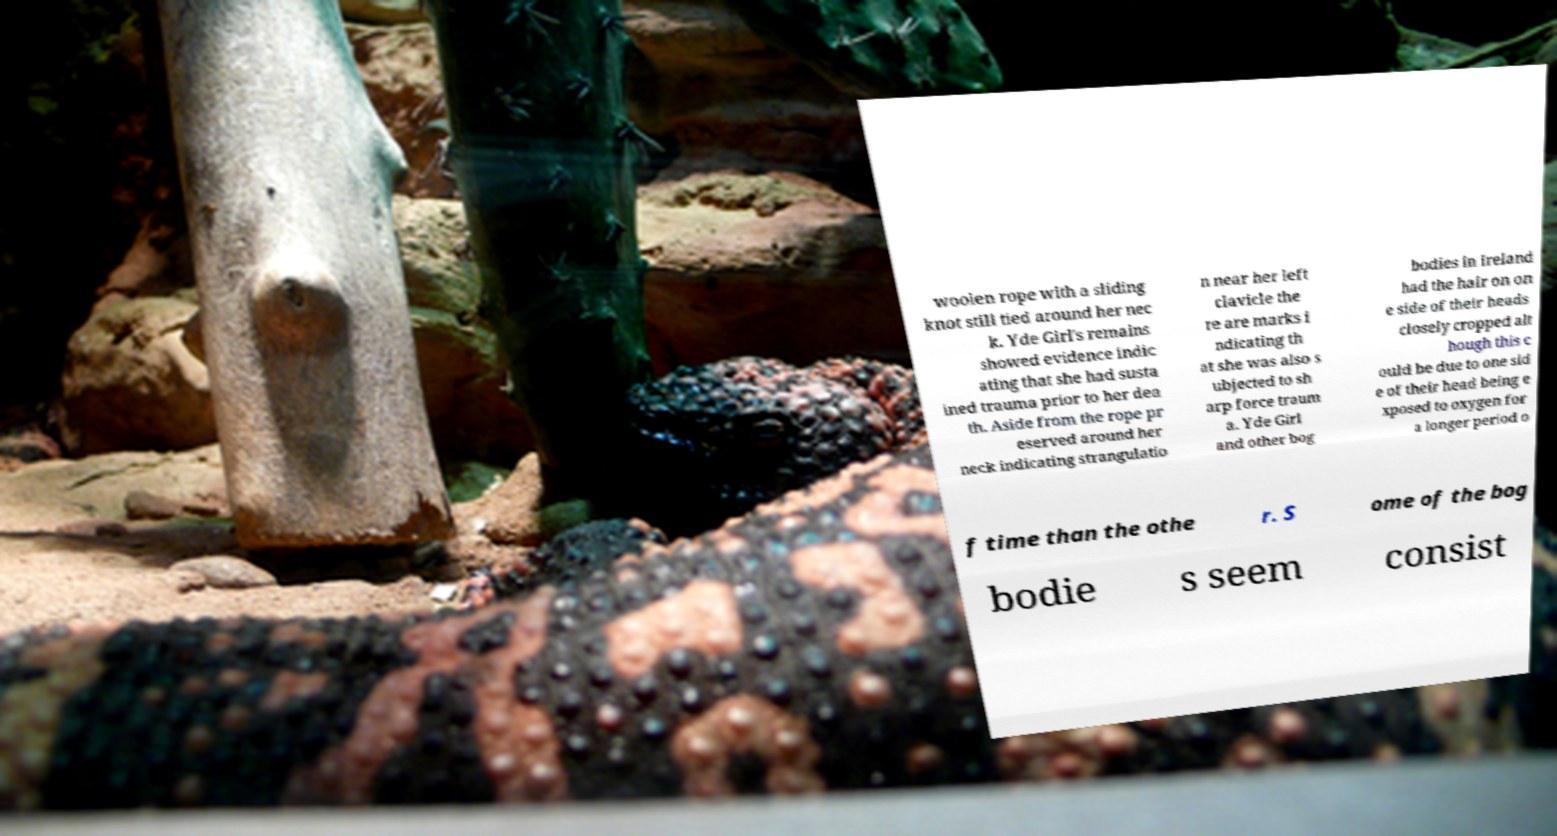Could you assist in decoding the text presented in this image and type it out clearly? woolen rope with a sliding knot still tied around her nec k. Yde Girl's remains showed evidence indic ating that she had susta ined trauma prior to her dea th. Aside from the rope pr eserved around her neck indicating strangulatio n near her left clavicle the re are marks i ndicating th at she was also s ubjected to sh arp force traum a. Yde Girl and other bog bodies in Ireland had the hair on on e side of their heads closely cropped alt hough this c ould be due to one sid e of their head being e xposed to oxygen for a longer period o f time than the othe r. S ome of the bog bodie s seem consist 